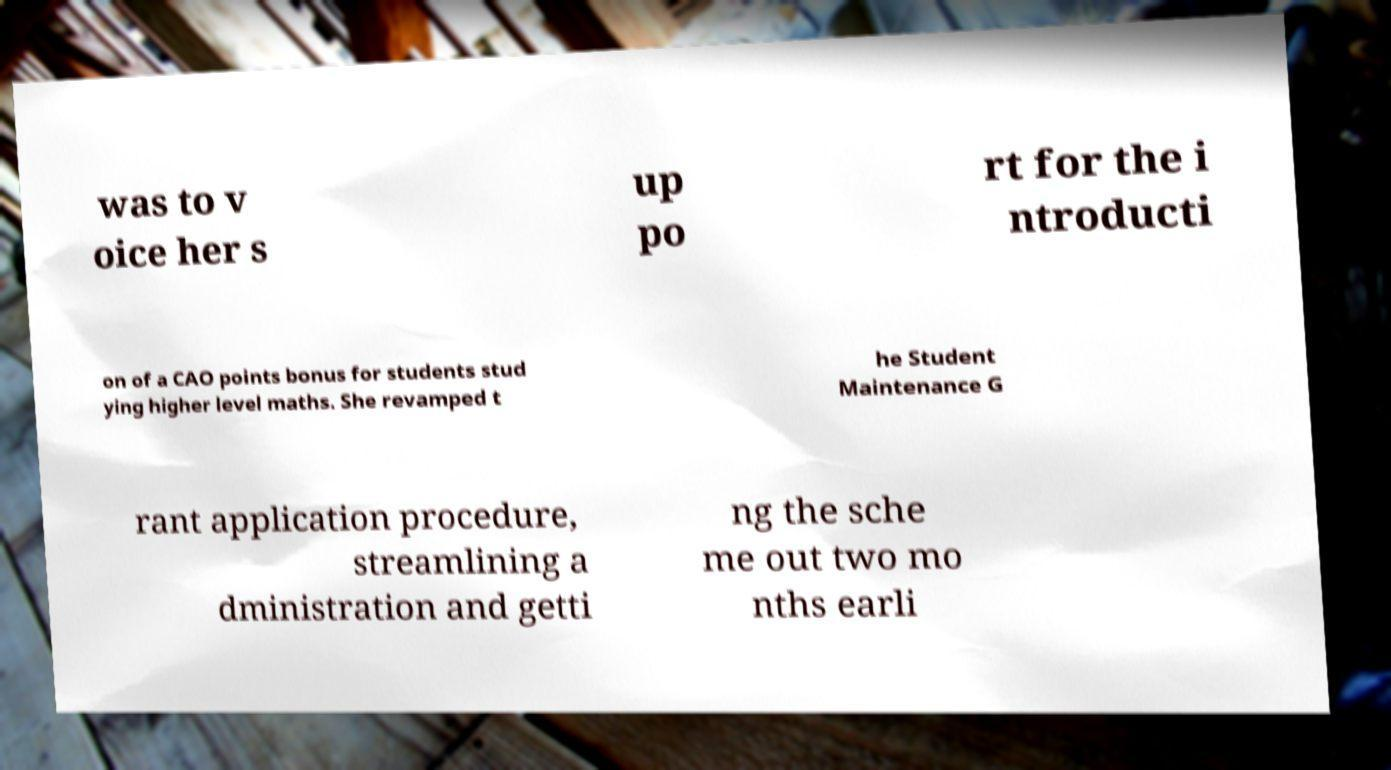Can you read and provide the text displayed in the image?This photo seems to have some interesting text. Can you extract and type it out for me? was to v oice her s up po rt for the i ntroducti on of a CAO points bonus for students stud ying higher level maths. She revamped t he Student Maintenance G rant application procedure, streamlining a dministration and getti ng the sche me out two mo nths earli 